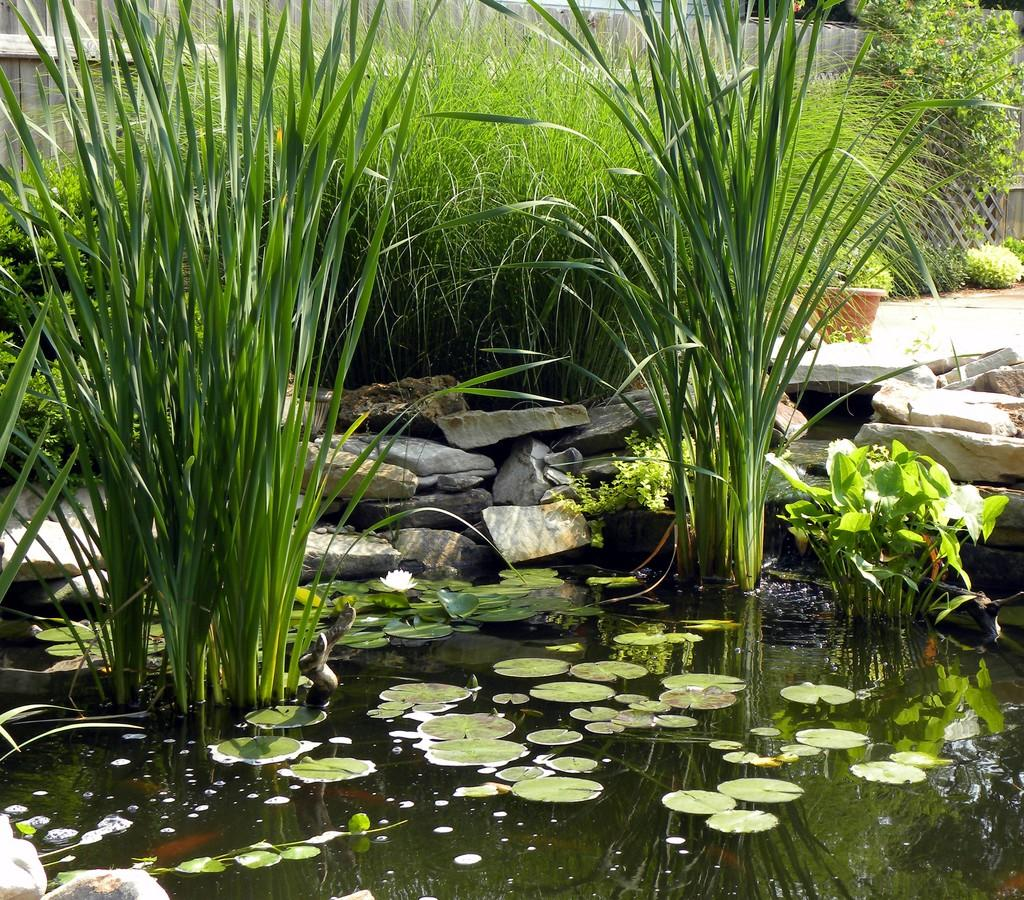What is the main subject in the center of the image? There are plants in the center of the image. What is located at the bottom of the image? There is a pond at the bottom of the image. What can be found near the pond? There are rocks near the pond. What is visible in the background of the image? There is a wall in the background of the image. Where is the faucet located in the image? There is no faucet present in the image. What type of toothpaste is used to clean the plants in the image? There is no toothpaste mentioned or visible in the image; plants do not require toothpaste for cleaning. 